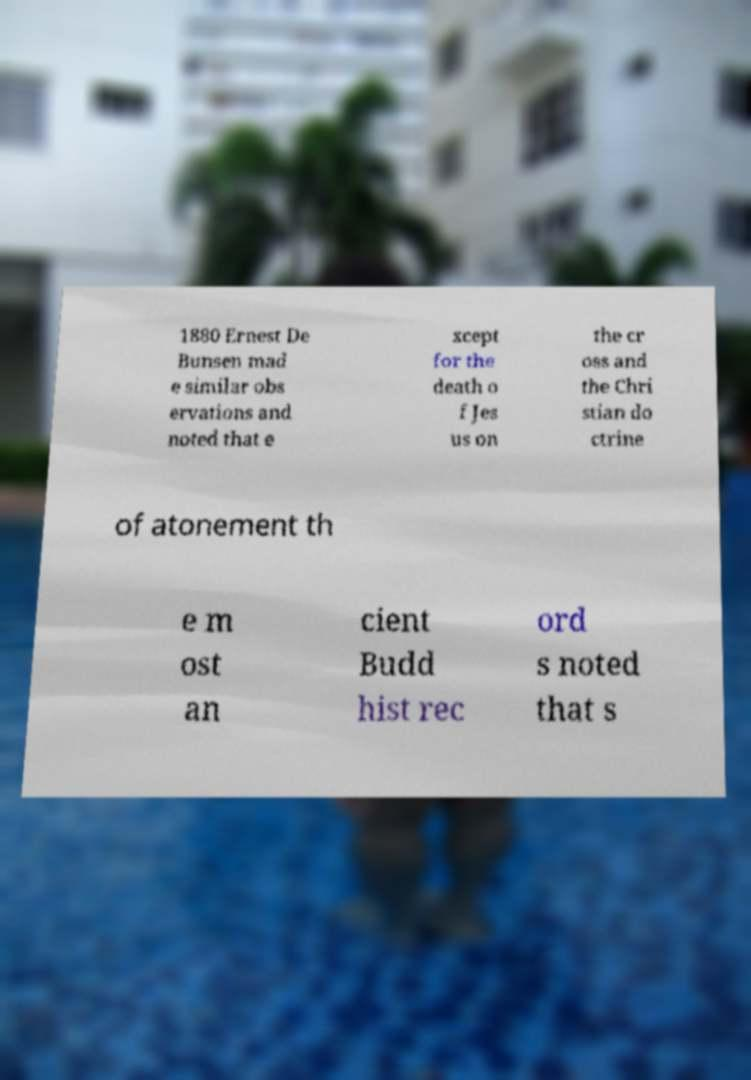Please read and relay the text visible in this image. What does it say? 1880 Ernest De Bunsen mad e similar obs ervations and noted that e xcept for the death o f Jes us on the cr oss and the Chri stian do ctrine of atonement th e m ost an cient Budd hist rec ord s noted that s 